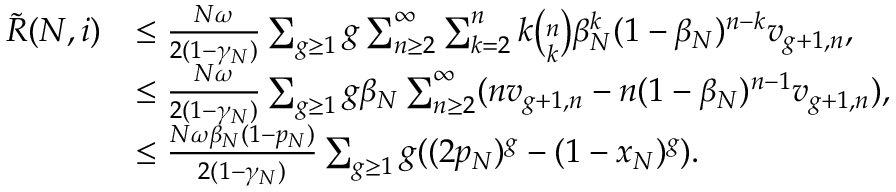Convert formula to latex. <formula><loc_0><loc_0><loc_500><loc_500>\begin{array} { r l } { \tilde { R } ( N , i ) } & { \leq \frac { N \omega } { 2 ( 1 - \gamma _ { N } ) } \sum _ { g \geq 1 } g \sum _ { n \geq 2 } ^ { \infty } \sum _ { k = 2 } ^ { n } k \binom { n } { k } \beta _ { N } ^ { k } ( 1 - \beta _ { N } ) ^ { n - k } v _ { g + 1 , n } , } \\ & { \leq \frac { N \omega } { 2 ( 1 - \gamma _ { N } ) } \sum _ { g \geq 1 } g \beta _ { N } \sum _ { n \geq 2 } ^ { \infty } ( n v _ { g + 1 , n } - n ( 1 - \beta _ { N } ) ^ { n - 1 } v _ { g + 1 , n } ) , } \\ & { \leq \frac { N \omega \beta _ { N } ( 1 - p _ { N } ) } { 2 ( 1 - \gamma _ { N } ) } \sum _ { g \geq 1 } g ( ( 2 p _ { N } ) ^ { g } - ( 1 - x _ { N } ) ^ { g } ) . } \end{array}</formula> 